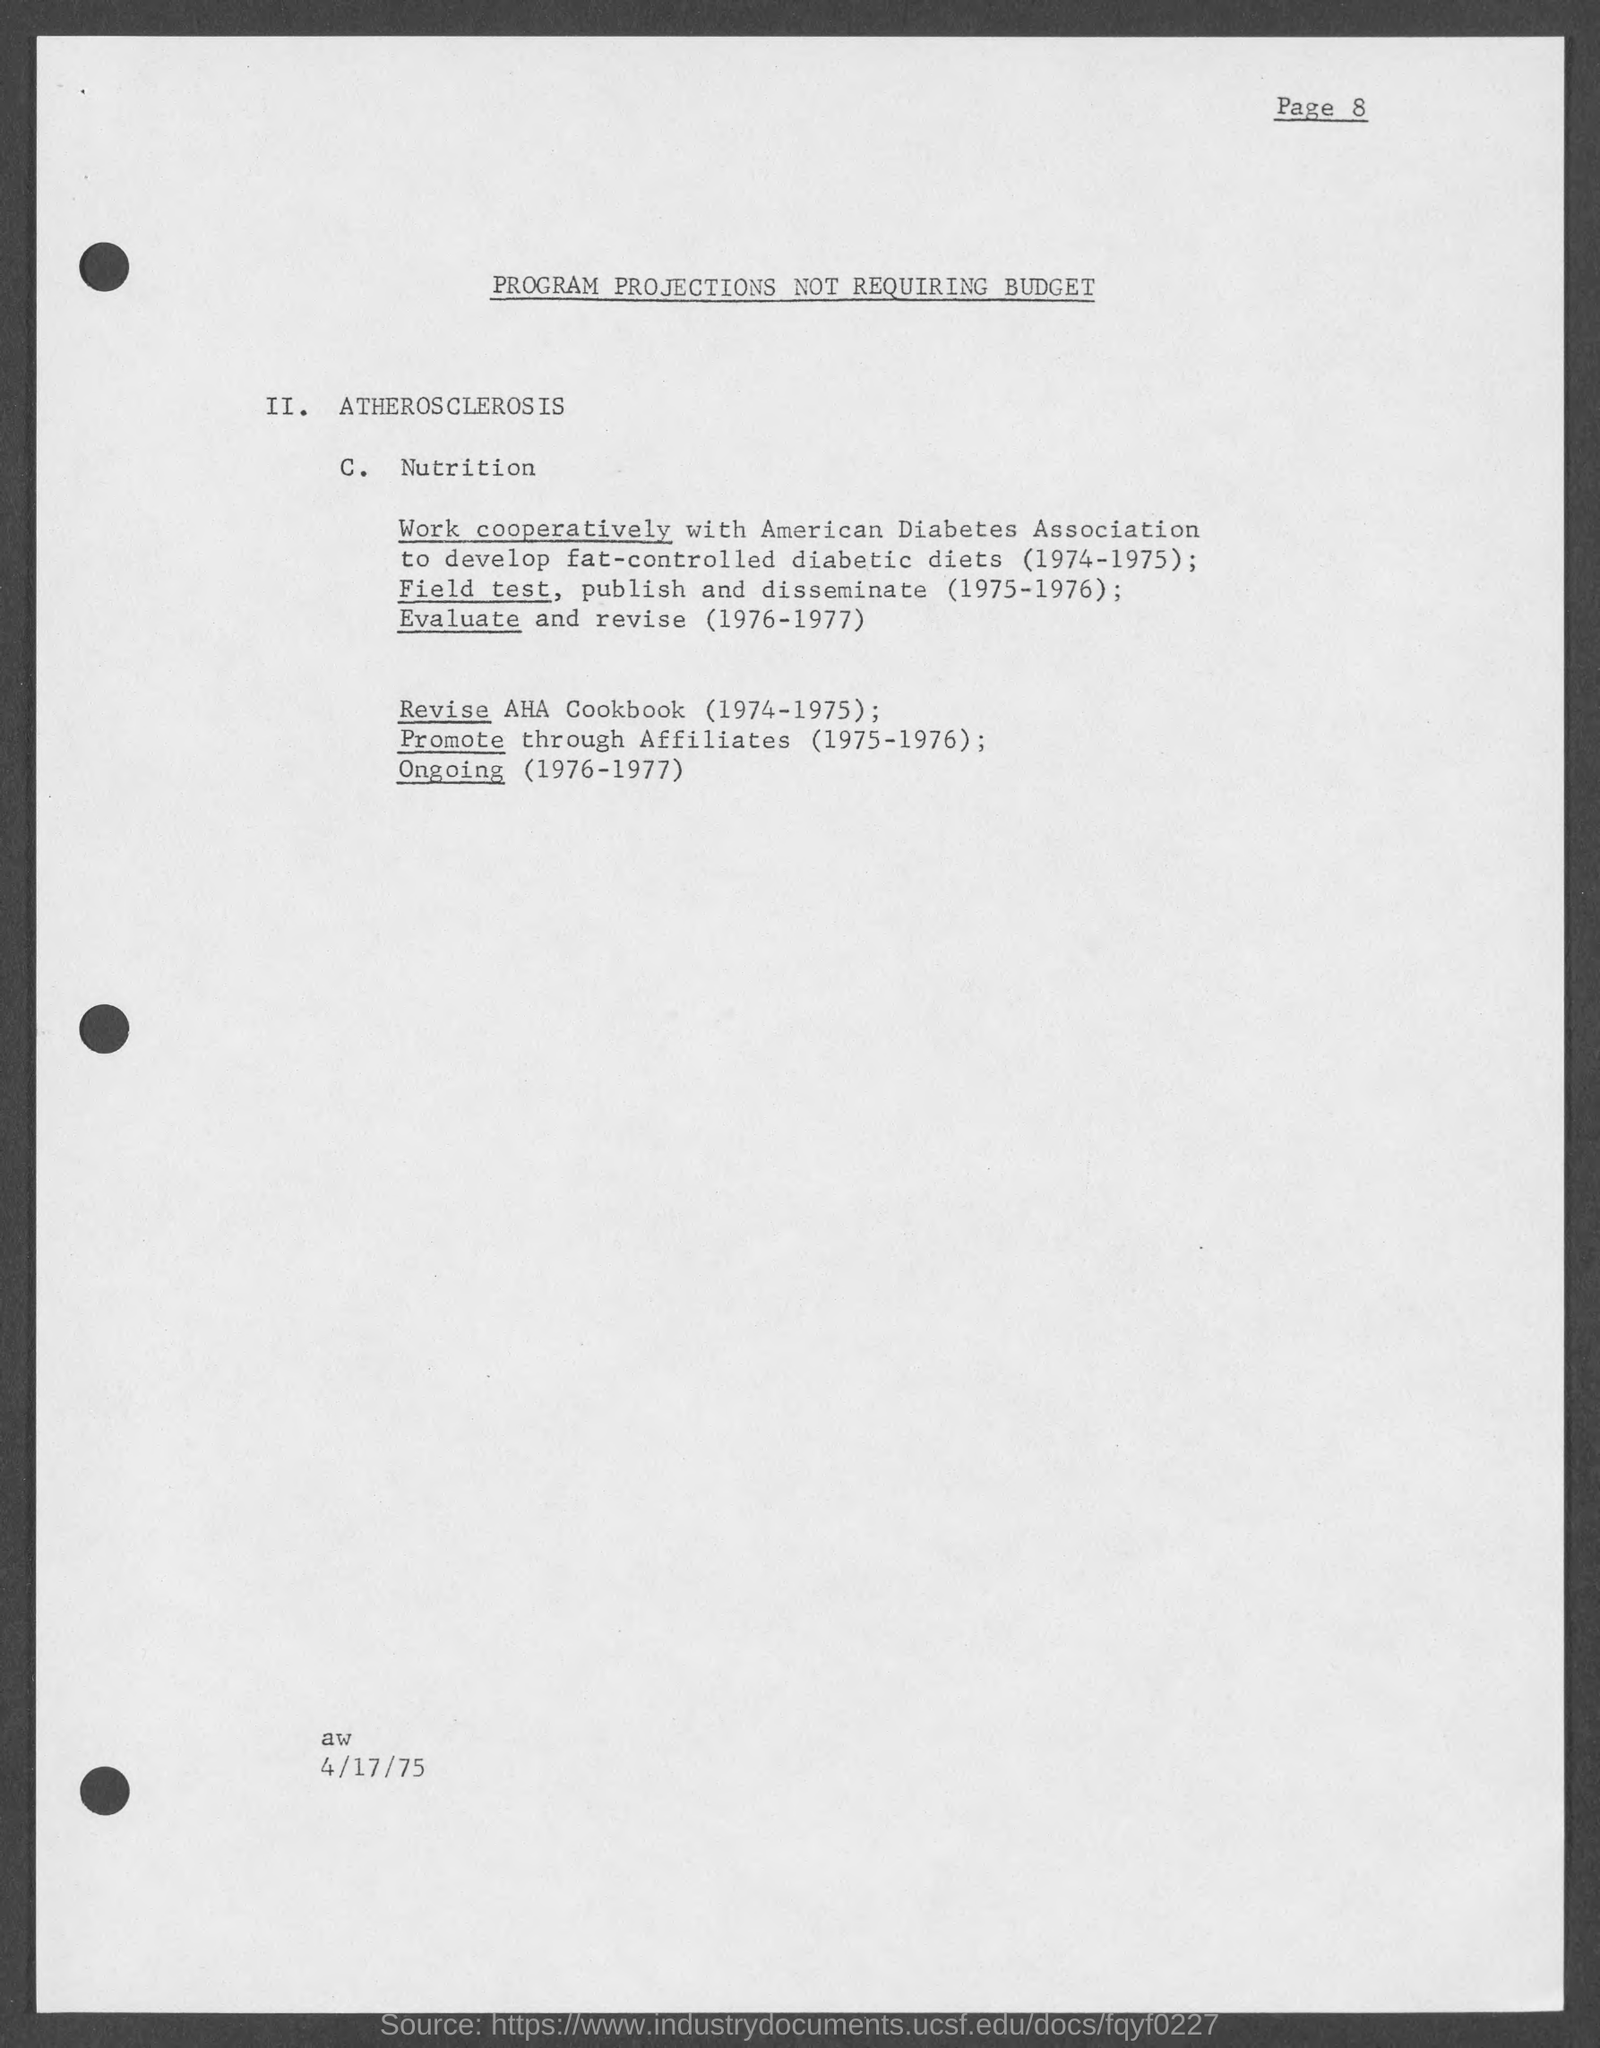What is the page number on this document?
Give a very brief answer. 8. When to revise AHA Cookbook?
Your response must be concise. 1974-1975. 